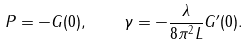<formula> <loc_0><loc_0><loc_500><loc_500>P = - G ( 0 ) , \quad \gamma = - \frac { \lambda } { 8 \pi ^ { 2 } L } G ^ { \prime } ( 0 ) .</formula> 